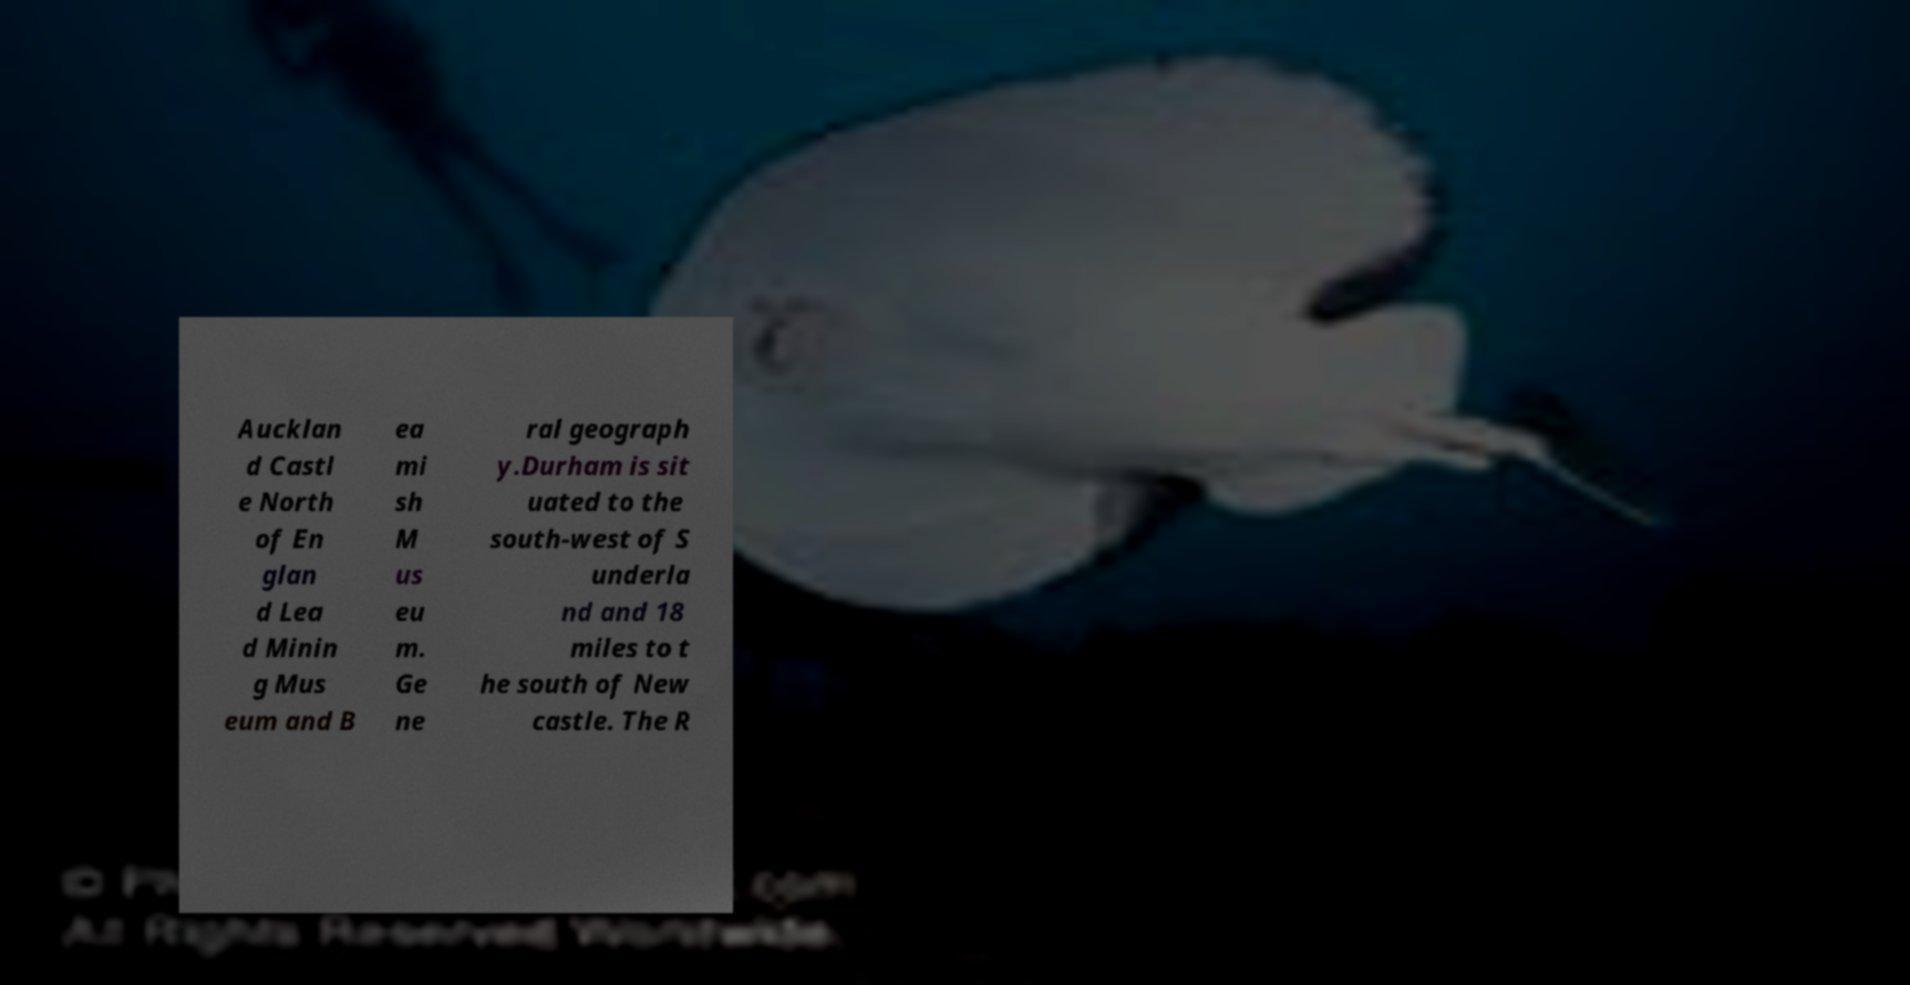I need the written content from this picture converted into text. Can you do that? Aucklan d Castl e North of En glan d Lea d Minin g Mus eum and B ea mi sh M us eu m. Ge ne ral geograph y.Durham is sit uated to the south-west of S underla nd and 18 miles to t he south of New castle. The R 